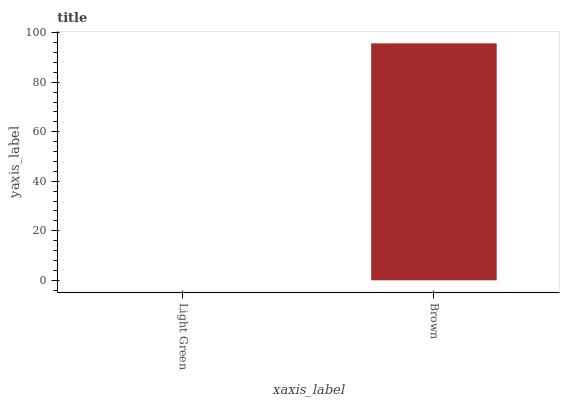Is Light Green the minimum?
Answer yes or no. Yes. Is Brown the maximum?
Answer yes or no. Yes. Is Brown the minimum?
Answer yes or no. No. Is Brown greater than Light Green?
Answer yes or no. Yes. Is Light Green less than Brown?
Answer yes or no. Yes. Is Light Green greater than Brown?
Answer yes or no. No. Is Brown less than Light Green?
Answer yes or no. No. Is Brown the high median?
Answer yes or no. Yes. Is Light Green the low median?
Answer yes or no. Yes. Is Light Green the high median?
Answer yes or no. No. Is Brown the low median?
Answer yes or no. No. 